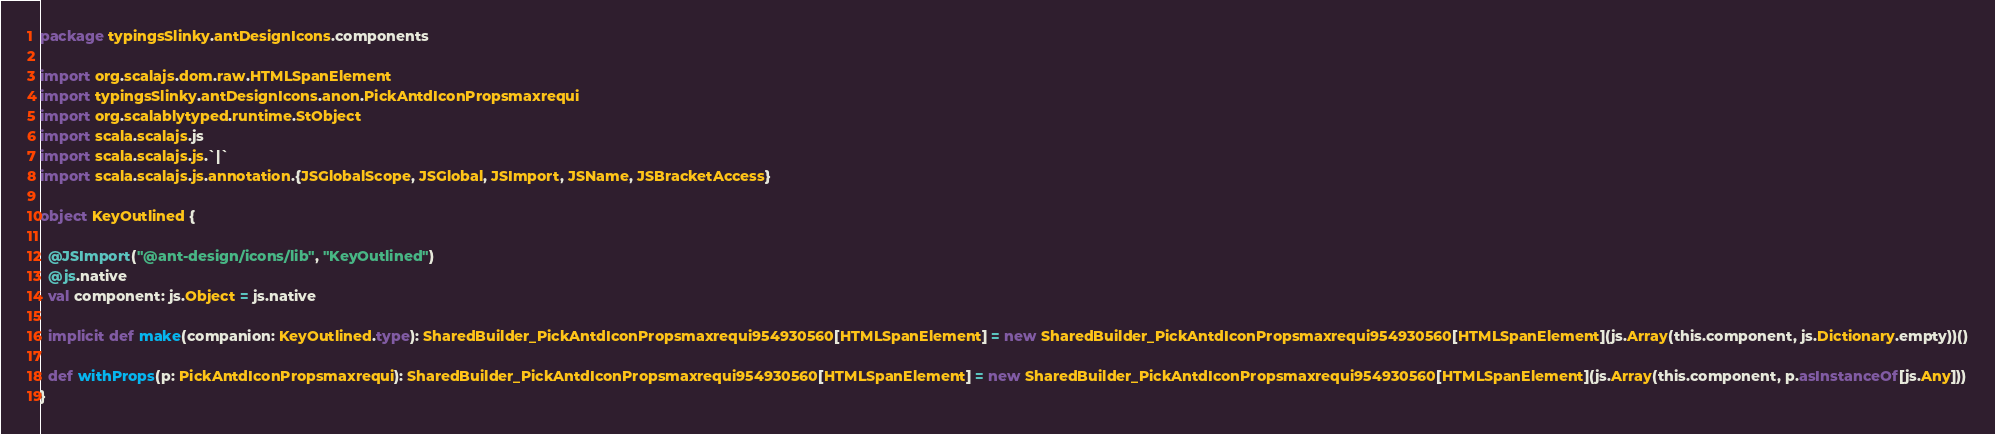Convert code to text. <code><loc_0><loc_0><loc_500><loc_500><_Scala_>package typingsSlinky.antDesignIcons.components

import org.scalajs.dom.raw.HTMLSpanElement
import typingsSlinky.antDesignIcons.anon.PickAntdIconPropsmaxrequi
import org.scalablytyped.runtime.StObject
import scala.scalajs.js
import scala.scalajs.js.`|`
import scala.scalajs.js.annotation.{JSGlobalScope, JSGlobal, JSImport, JSName, JSBracketAccess}

object KeyOutlined {
  
  @JSImport("@ant-design/icons/lib", "KeyOutlined")
  @js.native
  val component: js.Object = js.native
  
  implicit def make(companion: KeyOutlined.type): SharedBuilder_PickAntdIconPropsmaxrequi954930560[HTMLSpanElement] = new SharedBuilder_PickAntdIconPropsmaxrequi954930560[HTMLSpanElement](js.Array(this.component, js.Dictionary.empty))()
  
  def withProps(p: PickAntdIconPropsmaxrequi): SharedBuilder_PickAntdIconPropsmaxrequi954930560[HTMLSpanElement] = new SharedBuilder_PickAntdIconPropsmaxrequi954930560[HTMLSpanElement](js.Array(this.component, p.asInstanceOf[js.Any]))
}
</code> 